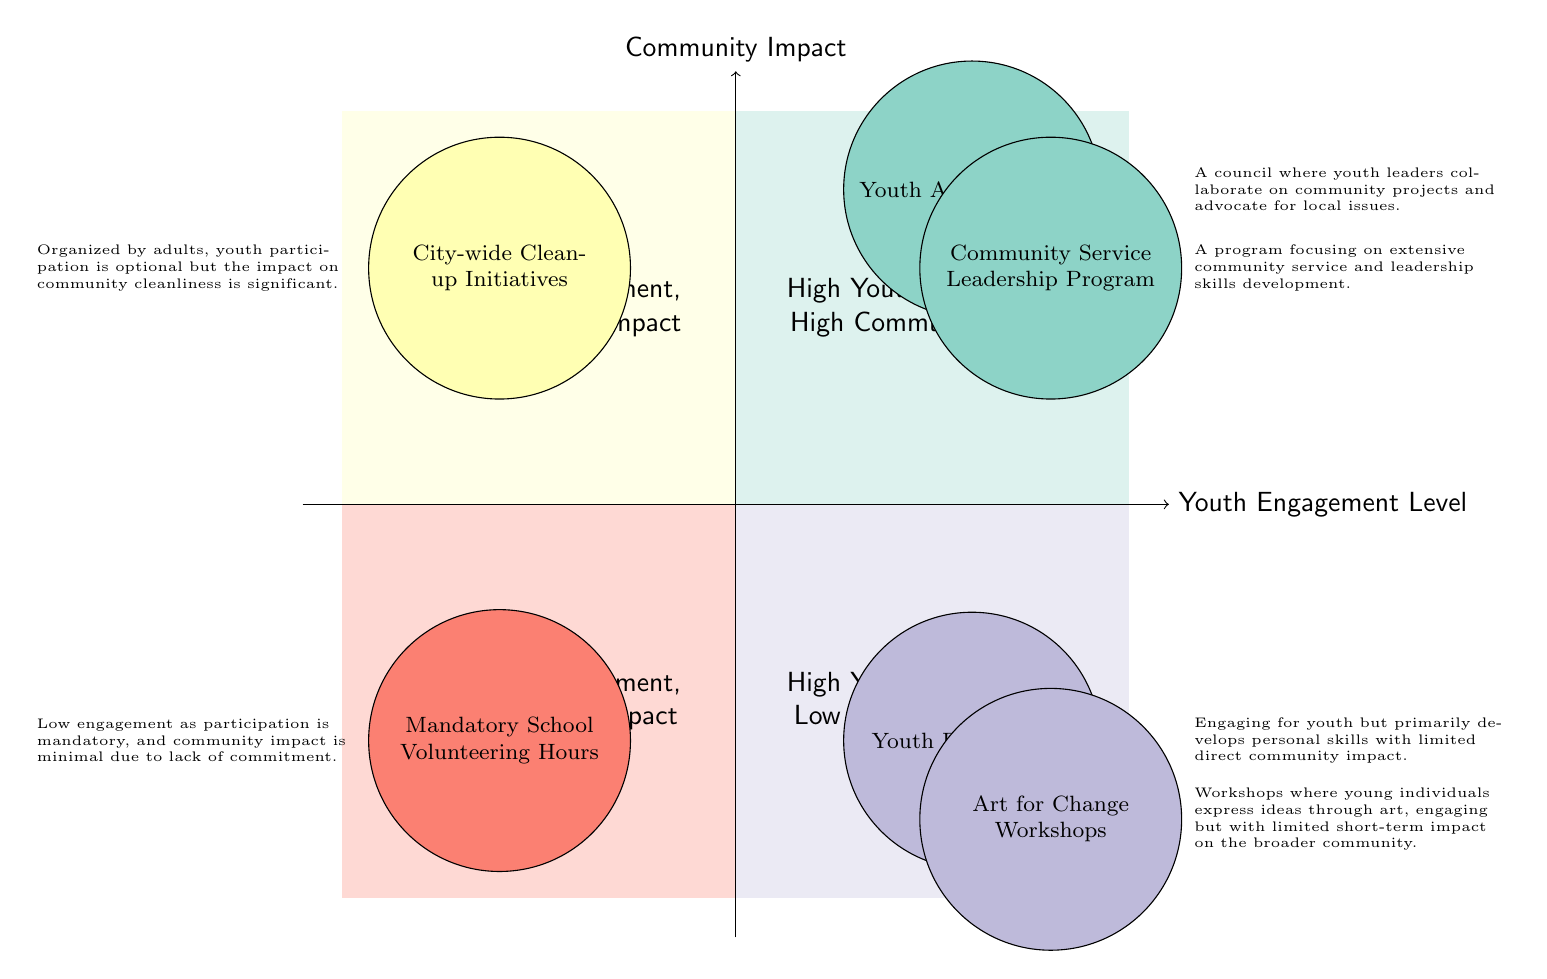What programs are located in the "High Youth Engagement, High Community Impact" quadrant? The first quadrant, which represents both high engagement and high community impact, includes the "Youth Action Council" and the "Community Service Leadership Program." These programs are designed to actively involve youth in significant community issues while developing leadership skills.
Answer: Youth Action Council, Community Service Leadership Program How many programs are categorized under "Low Youth Engagement, Low Community Impact"? In the quadrant labeled "Low Youth Engagement, Low Community Impact," there is one program listed: "Mandatory School Volunteering Hours." Therefore, the count of programs in this quadrant is one.
Answer: 1 What is the primary focus of the "Youth Debate Club"? The "Youth Debate Club" primarily focuses on engaging youth in debates, which enhances their personal skills. However, its role in community impact is limited and does not directly affect the broader community significantly.
Answer: Develops personal skills Which quadrant contains the "City-wide Clean-up Initiatives" program? The "City-wide Clean-up Initiatives" program is located in the "Low Youth Engagement, High Community Impact" quadrant. This indicates that while youth involvement is low, the program has a significant positive effect on the community's cleanliness.
Answer: Low Youth Engagement, High Community Impact How do the "Art for Change Workshops" rank in terms of community impact despite having high youth engagement? The "Art for Change Workshops" rank in the "High Youth Engagement, Low Community Impact" quadrant, which means they successfully engage youth but have a limited effect on the community overall in terms of immediate impact.
Answer: High Youth Engagement, Low Community Impact What two quadrants feature programs that involve high youth engagement? The two quadrants that feature programs with high youth engagement are "High Youth Engagement, High Community Impact" and "High Youth Engagement, Low Community Impact." This shows a distinction between programs that are impactful versus those that are not, despite strong youth involvement.
Answer: High Youth Engagement, High Community Impact; High Youth Engagement, Low Community Impact 